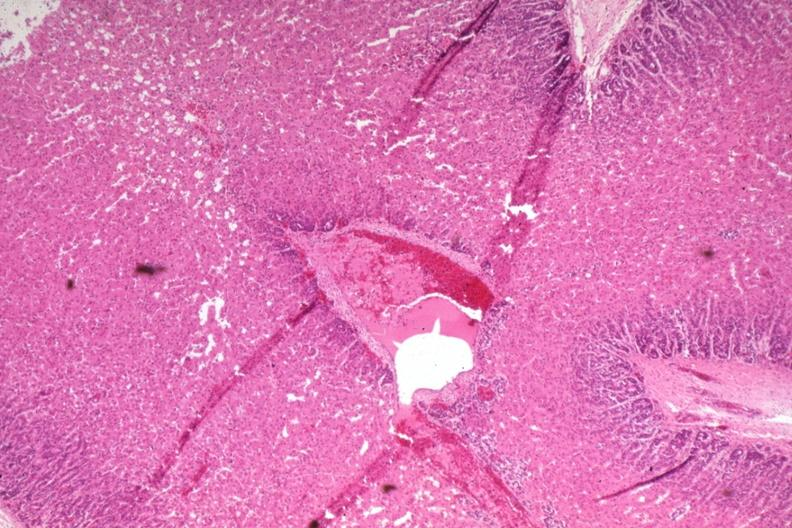s endocrine present?
Answer the question using a single word or phrase. Yes 